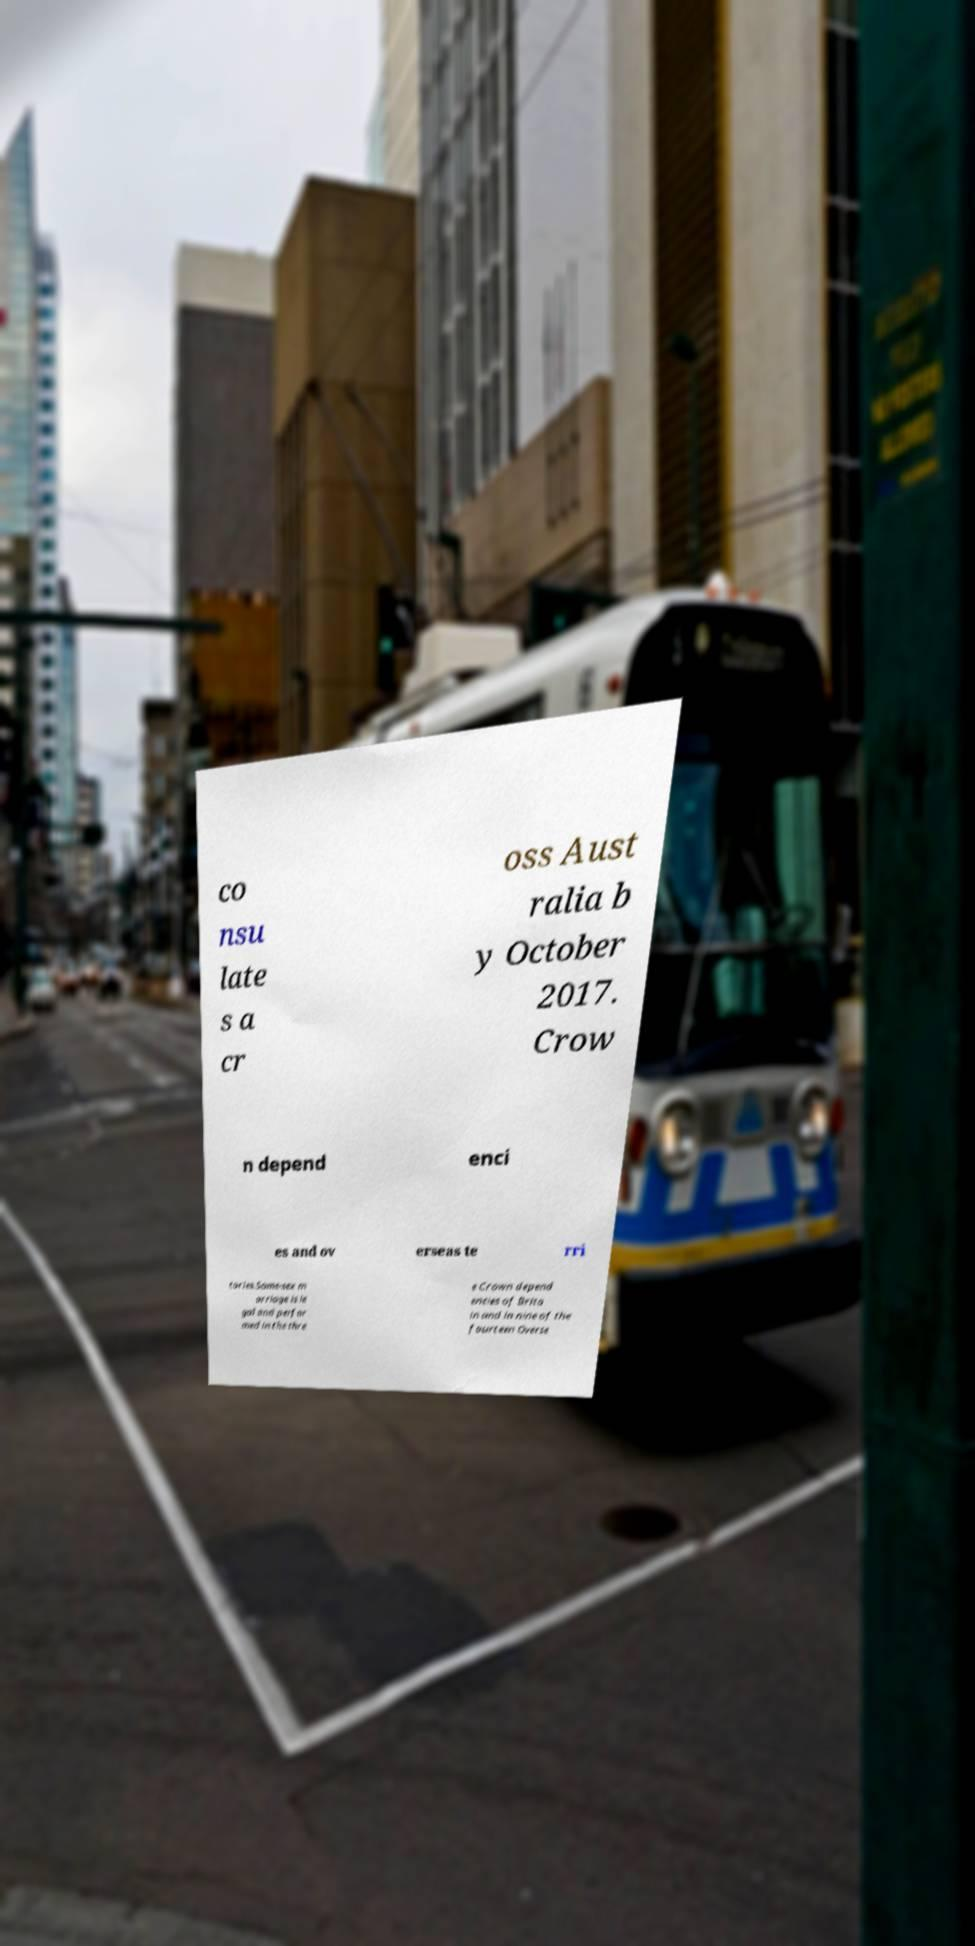Can you accurately transcribe the text from the provided image for me? co nsu late s a cr oss Aust ralia b y October 2017. Crow n depend enci es and ov erseas te rri tories.Same-sex m arriage is le gal and perfor med in the thre e Crown depend encies of Brita in and in nine of the fourteen Overse 